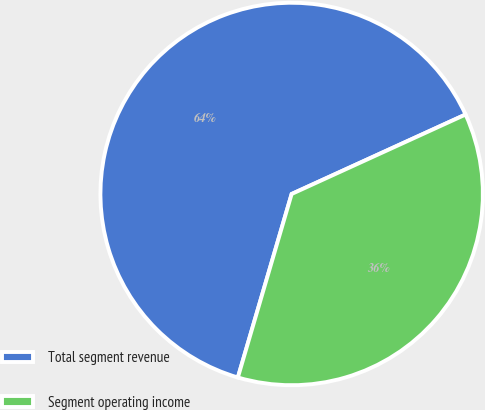Convert chart. <chart><loc_0><loc_0><loc_500><loc_500><pie_chart><fcel>Total segment revenue<fcel>Segment operating income<nl><fcel>63.64%<fcel>36.36%<nl></chart> 